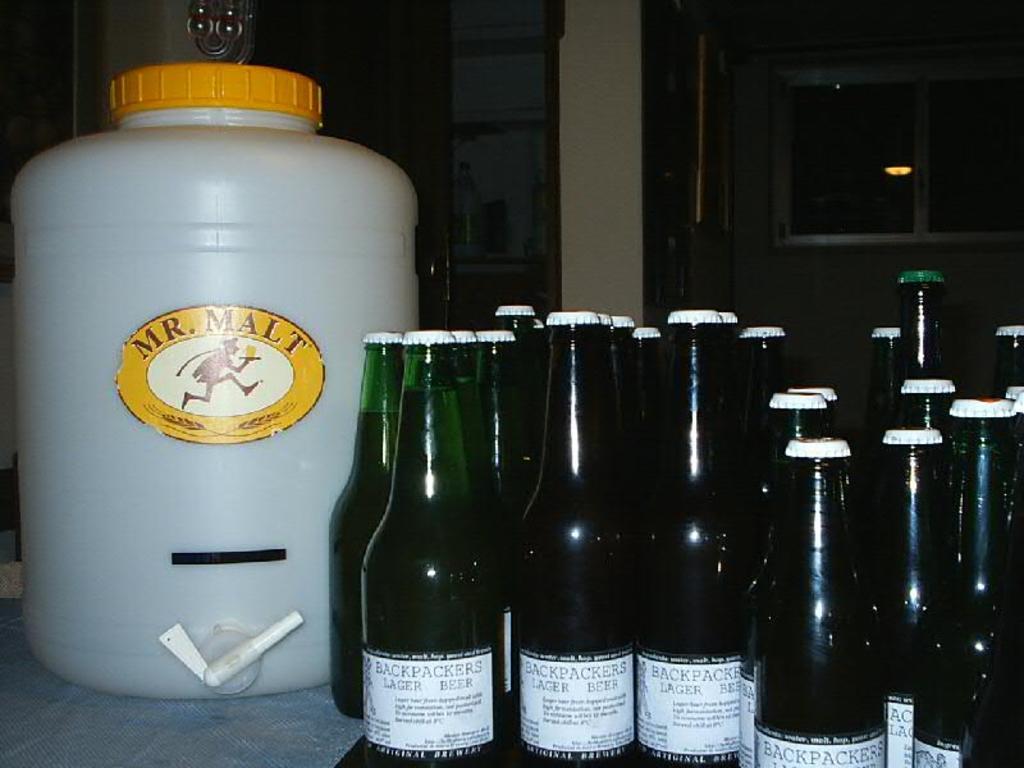What does the big white container say?
Provide a succinct answer. Mr. malt. What is the name of the beer?
Provide a short and direct response. Backpackers. 